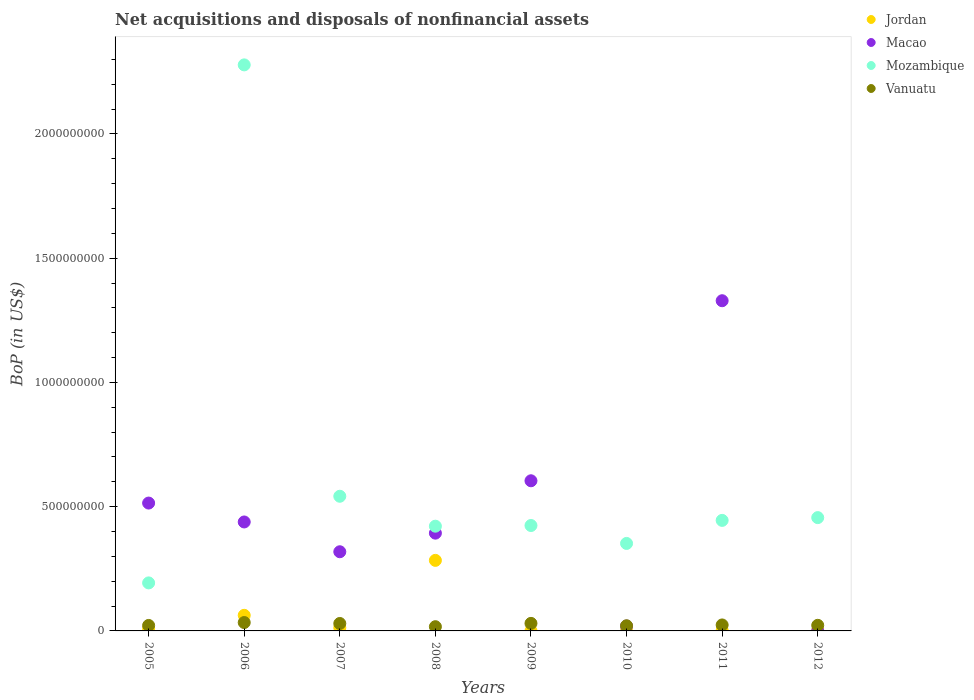How many different coloured dotlines are there?
Ensure brevity in your answer.  4. What is the Balance of Payments in Mozambique in 2011?
Provide a succinct answer. 4.45e+08. Across all years, what is the maximum Balance of Payments in Jordan?
Provide a succinct answer. 2.84e+08. Across all years, what is the minimum Balance of Payments in Macao?
Give a very brief answer. 0. What is the total Balance of Payments in Jordan in the graph?
Offer a terse response. 3.74e+08. What is the difference between the Balance of Payments in Macao in 2006 and that in 2009?
Provide a succinct answer. -1.66e+08. What is the difference between the Balance of Payments in Jordan in 2006 and the Balance of Payments in Macao in 2012?
Keep it short and to the point. 6.28e+07. What is the average Balance of Payments in Mozambique per year?
Your answer should be compact. 6.39e+08. In the year 2010, what is the difference between the Balance of Payments in Mozambique and Balance of Payments in Macao?
Keep it short and to the point. 3.32e+08. In how many years, is the Balance of Payments in Macao greater than 600000000 US$?
Your answer should be very brief. 2. What is the ratio of the Balance of Payments in Vanuatu in 2005 to that in 2011?
Give a very brief answer. 0.92. Is the Balance of Payments in Mozambique in 2007 less than that in 2008?
Make the answer very short. No. Is the difference between the Balance of Payments in Mozambique in 2006 and 2007 greater than the difference between the Balance of Payments in Macao in 2006 and 2007?
Your answer should be compact. Yes. What is the difference between the highest and the second highest Balance of Payments in Mozambique?
Your answer should be compact. 1.74e+09. What is the difference between the highest and the lowest Balance of Payments in Mozambique?
Your response must be concise. 2.08e+09. Is it the case that in every year, the sum of the Balance of Payments in Vanuatu and Balance of Payments in Macao  is greater than the sum of Balance of Payments in Mozambique and Balance of Payments in Jordan?
Provide a short and direct response. No. Is it the case that in every year, the sum of the Balance of Payments in Mozambique and Balance of Payments in Jordan  is greater than the Balance of Payments in Vanuatu?
Your answer should be very brief. Yes. How many years are there in the graph?
Your answer should be very brief. 8. What is the difference between two consecutive major ticks on the Y-axis?
Provide a short and direct response. 5.00e+08. How many legend labels are there?
Your response must be concise. 4. What is the title of the graph?
Provide a succinct answer. Net acquisitions and disposals of nonfinancial assets. Does "Equatorial Guinea" appear as one of the legend labels in the graph?
Give a very brief answer. No. What is the label or title of the X-axis?
Provide a succinct answer. Years. What is the label or title of the Y-axis?
Provide a succinct answer. BoP (in US$). What is the BoP (in US$) of Jordan in 2005?
Your response must be concise. 8.46e+06. What is the BoP (in US$) of Macao in 2005?
Make the answer very short. 5.15e+08. What is the BoP (in US$) in Mozambique in 2005?
Keep it short and to the point. 1.93e+08. What is the BoP (in US$) in Vanuatu in 2005?
Your answer should be compact. 2.21e+07. What is the BoP (in US$) in Jordan in 2006?
Your answer should be compact. 6.28e+07. What is the BoP (in US$) of Macao in 2006?
Provide a short and direct response. 4.38e+08. What is the BoP (in US$) of Mozambique in 2006?
Provide a short and direct response. 2.28e+09. What is the BoP (in US$) of Vanuatu in 2006?
Provide a short and direct response. 3.37e+07. What is the BoP (in US$) of Jordan in 2007?
Your answer should be compact. 1.28e+07. What is the BoP (in US$) of Macao in 2007?
Offer a very short reply. 3.19e+08. What is the BoP (in US$) in Mozambique in 2007?
Ensure brevity in your answer.  5.42e+08. What is the BoP (in US$) in Vanuatu in 2007?
Provide a short and direct response. 3.00e+07. What is the BoP (in US$) in Jordan in 2008?
Offer a terse response. 2.84e+08. What is the BoP (in US$) of Macao in 2008?
Give a very brief answer. 3.93e+08. What is the BoP (in US$) of Mozambique in 2008?
Offer a terse response. 4.21e+08. What is the BoP (in US$) in Vanuatu in 2008?
Give a very brief answer. 1.70e+07. What is the BoP (in US$) of Jordan in 2009?
Offer a very short reply. 5.63e+05. What is the BoP (in US$) in Macao in 2009?
Keep it short and to the point. 6.04e+08. What is the BoP (in US$) in Mozambique in 2009?
Keep it short and to the point. 4.24e+08. What is the BoP (in US$) of Vanuatu in 2009?
Provide a succinct answer. 3.04e+07. What is the BoP (in US$) in Jordan in 2010?
Provide a succinct answer. 2.82e+05. What is the BoP (in US$) in Macao in 2010?
Keep it short and to the point. 1.96e+07. What is the BoP (in US$) in Mozambique in 2010?
Your answer should be compact. 3.52e+08. What is the BoP (in US$) in Vanuatu in 2010?
Your answer should be very brief. 2.07e+07. What is the BoP (in US$) in Jordan in 2011?
Your answer should be compact. 2.25e+06. What is the BoP (in US$) of Macao in 2011?
Offer a terse response. 1.33e+09. What is the BoP (in US$) in Mozambique in 2011?
Offer a terse response. 4.45e+08. What is the BoP (in US$) in Vanuatu in 2011?
Offer a terse response. 2.40e+07. What is the BoP (in US$) of Jordan in 2012?
Give a very brief answer. 2.54e+06. What is the BoP (in US$) of Mozambique in 2012?
Your answer should be compact. 4.56e+08. What is the BoP (in US$) in Vanuatu in 2012?
Give a very brief answer. 2.26e+07. Across all years, what is the maximum BoP (in US$) of Jordan?
Offer a very short reply. 2.84e+08. Across all years, what is the maximum BoP (in US$) of Macao?
Ensure brevity in your answer.  1.33e+09. Across all years, what is the maximum BoP (in US$) in Mozambique?
Provide a succinct answer. 2.28e+09. Across all years, what is the maximum BoP (in US$) in Vanuatu?
Provide a short and direct response. 3.37e+07. Across all years, what is the minimum BoP (in US$) of Jordan?
Offer a very short reply. 2.82e+05. Across all years, what is the minimum BoP (in US$) in Mozambique?
Keep it short and to the point. 1.93e+08. Across all years, what is the minimum BoP (in US$) in Vanuatu?
Offer a terse response. 1.70e+07. What is the total BoP (in US$) of Jordan in the graph?
Provide a succinct answer. 3.74e+08. What is the total BoP (in US$) of Macao in the graph?
Keep it short and to the point. 3.62e+09. What is the total BoP (in US$) in Mozambique in the graph?
Keep it short and to the point. 5.11e+09. What is the total BoP (in US$) in Vanuatu in the graph?
Provide a succinct answer. 2.00e+08. What is the difference between the BoP (in US$) of Jordan in 2005 and that in 2006?
Your answer should be compact. -5.43e+07. What is the difference between the BoP (in US$) of Macao in 2005 and that in 2006?
Your answer should be very brief. 7.61e+07. What is the difference between the BoP (in US$) of Mozambique in 2005 and that in 2006?
Your answer should be very brief. -2.08e+09. What is the difference between the BoP (in US$) of Vanuatu in 2005 and that in 2006?
Provide a succinct answer. -1.17e+07. What is the difference between the BoP (in US$) in Jordan in 2005 and that in 2007?
Offer a very short reply. -4.37e+06. What is the difference between the BoP (in US$) in Macao in 2005 and that in 2007?
Provide a succinct answer. 1.96e+08. What is the difference between the BoP (in US$) in Mozambique in 2005 and that in 2007?
Provide a short and direct response. -3.49e+08. What is the difference between the BoP (in US$) in Vanuatu in 2005 and that in 2007?
Ensure brevity in your answer.  -7.89e+06. What is the difference between the BoP (in US$) of Jordan in 2005 and that in 2008?
Your answer should be very brief. -2.75e+08. What is the difference between the BoP (in US$) of Macao in 2005 and that in 2008?
Keep it short and to the point. 1.21e+08. What is the difference between the BoP (in US$) of Mozambique in 2005 and that in 2008?
Give a very brief answer. -2.28e+08. What is the difference between the BoP (in US$) in Vanuatu in 2005 and that in 2008?
Offer a terse response. 5.06e+06. What is the difference between the BoP (in US$) in Jordan in 2005 and that in 2009?
Provide a succinct answer. 7.90e+06. What is the difference between the BoP (in US$) of Macao in 2005 and that in 2009?
Your answer should be very brief. -8.97e+07. What is the difference between the BoP (in US$) in Mozambique in 2005 and that in 2009?
Make the answer very short. -2.31e+08. What is the difference between the BoP (in US$) in Vanuatu in 2005 and that in 2009?
Make the answer very short. -8.30e+06. What is the difference between the BoP (in US$) of Jordan in 2005 and that in 2010?
Your response must be concise. 8.18e+06. What is the difference between the BoP (in US$) in Macao in 2005 and that in 2010?
Make the answer very short. 4.95e+08. What is the difference between the BoP (in US$) of Mozambique in 2005 and that in 2010?
Your answer should be compact. -1.59e+08. What is the difference between the BoP (in US$) in Vanuatu in 2005 and that in 2010?
Keep it short and to the point. 1.34e+06. What is the difference between the BoP (in US$) in Jordan in 2005 and that in 2011?
Provide a short and direct response. 6.21e+06. What is the difference between the BoP (in US$) in Macao in 2005 and that in 2011?
Make the answer very short. -8.14e+08. What is the difference between the BoP (in US$) of Mozambique in 2005 and that in 2011?
Provide a short and direct response. -2.52e+08. What is the difference between the BoP (in US$) of Vanuatu in 2005 and that in 2011?
Give a very brief answer. -1.98e+06. What is the difference between the BoP (in US$) of Jordan in 2005 and that in 2012?
Provide a short and direct response. 5.93e+06. What is the difference between the BoP (in US$) of Mozambique in 2005 and that in 2012?
Give a very brief answer. -2.63e+08. What is the difference between the BoP (in US$) in Vanuatu in 2005 and that in 2012?
Your response must be concise. -4.97e+05. What is the difference between the BoP (in US$) of Jordan in 2006 and that in 2007?
Provide a short and direct response. 4.99e+07. What is the difference between the BoP (in US$) of Macao in 2006 and that in 2007?
Give a very brief answer. 1.20e+08. What is the difference between the BoP (in US$) in Mozambique in 2006 and that in 2007?
Make the answer very short. 1.74e+09. What is the difference between the BoP (in US$) of Vanuatu in 2006 and that in 2007?
Give a very brief answer. 3.78e+06. What is the difference between the BoP (in US$) in Jordan in 2006 and that in 2008?
Provide a short and direct response. -2.21e+08. What is the difference between the BoP (in US$) of Macao in 2006 and that in 2008?
Your answer should be compact. 4.50e+07. What is the difference between the BoP (in US$) of Mozambique in 2006 and that in 2008?
Ensure brevity in your answer.  1.86e+09. What is the difference between the BoP (in US$) of Vanuatu in 2006 and that in 2008?
Make the answer very short. 1.67e+07. What is the difference between the BoP (in US$) of Jordan in 2006 and that in 2009?
Give a very brief answer. 6.22e+07. What is the difference between the BoP (in US$) in Macao in 2006 and that in 2009?
Provide a short and direct response. -1.66e+08. What is the difference between the BoP (in US$) in Mozambique in 2006 and that in 2009?
Offer a very short reply. 1.85e+09. What is the difference between the BoP (in US$) of Vanuatu in 2006 and that in 2009?
Make the answer very short. 3.37e+06. What is the difference between the BoP (in US$) in Jordan in 2006 and that in 2010?
Offer a terse response. 6.25e+07. What is the difference between the BoP (in US$) of Macao in 2006 and that in 2010?
Offer a very short reply. 4.19e+08. What is the difference between the BoP (in US$) of Mozambique in 2006 and that in 2010?
Offer a terse response. 1.93e+09. What is the difference between the BoP (in US$) of Vanuatu in 2006 and that in 2010?
Provide a succinct answer. 1.30e+07. What is the difference between the BoP (in US$) of Jordan in 2006 and that in 2011?
Make the answer very short. 6.05e+07. What is the difference between the BoP (in US$) in Macao in 2006 and that in 2011?
Provide a succinct answer. -8.90e+08. What is the difference between the BoP (in US$) of Mozambique in 2006 and that in 2011?
Offer a very short reply. 1.83e+09. What is the difference between the BoP (in US$) in Vanuatu in 2006 and that in 2011?
Your answer should be very brief. 9.69e+06. What is the difference between the BoP (in US$) of Jordan in 2006 and that in 2012?
Give a very brief answer. 6.02e+07. What is the difference between the BoP (in US$) in Mozambique in 2006 and that in 2012?
Your response must be concise. 1.82e+09. What is the difference between the BoP (in US$) of Vanuatu in 2006 and that in 2012?
Offer a terse response. 1.12e+07. What is the difference between the BoP (in US$) of Jordan in 2007 and that in 2008?
Offer a very short reply. -2.71e+08. What is the difference between the BoP (in US$) of Macao in 2007 and that in 2008?
Offer a terse response. -7.49e+07. What is the difference between the BoP (in US$) in Mozambique in 2007 and that in 2008?
Provide a succinct answer. 1.20e+08. What is the difference between the BoP (in US$) in Vanuatu in 2007 and that in 2008?
Your answer should be very brief. 1.30e+07. What is the difference between the BoP (in US$) in Jordan in 2007 and that in 2009?
Offer a terse response. 1.23e+07. What is the difference between the BoP (in US$) in Macao in 2007 and that in 2009?
Offer a terse response. -2.86e+08. What is the difference between the BoP (in US$) in Mozambique in 2007 and that in 2009?
Your answer should be compact. 1.18e+08. What is the difference between the BoP (in US$) in Vanuatu in 2007 and that in 2009?
Provide a succinct answer. -4.10e+05. What is the difference between the BoP (in US$) in Jordan in 2007 and that in 2010?
Keep it short and to the point. 1.26e+07. What is the difference between the BoP (in US$) of Macao in 2007 and that in 2010?
Give a very brief answer. 2.99e+08. What is the difference between the BoP (in US$) in Mozambique in 2007 and that in 2010?
Provide a succinct answer. 1.90e+08. What is the difference between the BoP (in US$) in Vanuatu in 2007 and that in 2010?
Offer a very short reply. 9.23e+06. What is the difference between the BoP (in US$) in Jordan in 2007 and that in 2011?
Your answer should be compact. 1.06e+07. What is the difference between the BoP (in US$) of Macao in 2007 and that in 2011?
Offer a very short reply. -1.01e+09. What is the difference between the BoP (in US$) of Mozambique in 2007 and that in 2011?
Offer a terse response. 9.71e+07. What is the difference between the BoP (in US$) in Vanuatu in 2007 and that in 2011?
Offer a very short reply. 5.92e+06. What is the difference between the BoP (in US$) of Jordan in 2007 and that in 2012?
Ensure brevity in your answer.  1.03e+07. What is the difference between the BoP (in US$) in Mozambique in 2007 and that in 2012?
Provide a short and direct response. 8.60e+07. What is the difference between the BoP (in US$) in Vanuatu in 2007 and that in 2012?
Make the answer very short. 7.39e+06. What is the difference between the BoP (in US$) of Jordan in 2008 and that in 2009?
Offer a very short reply. 2.83e+08. What is the difference between the BoP (in US$) in Macao in 2008 and that in 2009?
Offer a very short reply. -2.11e+08. What is the difference between the BoP (in US$) of Mozambique in 2008 and that in 2009?
Your answer should be very brief. -2.73e+06. What is the difference between the BoP (in US$) of Vanuatu in 2008 and that in 2009?
Your response must be concise. -1.34e+07. What is the difference between the BoP (in US$) of Jordan in 2008 and that in 2010?
Your answer should be very brief. 2.84e+08. What is the difference between the BoP (in US$) of Macao in 2008 and that in 2010?
Provide a succinct answer. 3.74e+08. What is the difference between the BoP (in US$) in Mozambique in 2008 and that in 2010?
Keep it short and to the point. 6.94e+07. What is the difference between the BoP (in US$) of Vanuatu in 2008 and that in 2010?
Offer a terse response. -3.72e+06. What is the difference between the BoP (in US$) of Jordan in 2008 and that in 2011?
Your response must be concise. 2.82e+08. What is the difference between the BoP (in US$) of Macao in 2008 and that in 2011?
Your answer should be very brief. -9.35e+08. What is the difference between the BoP (in US$) of Mozambique in 2008 and that in 2011?
Give a very brief answer. -2.33e+07. What is the difference between the BoP (in US$) of Vanuatu in 2008 and that in 2011?
Your answer should be very brief. -7.04e+06. What is the difference between the BoP (in US$) in Jordan in 2008 and that in 2012?
Offer a very short reply. 2.81e+08. What is the difference between the BoP (in US$) in Mozambique in 2008 and that in 2012?
Keep it short and to the point. -3.45e+07. What is the difference between the BoP (in US$) of Vanuatu in 2008 and that in 2012?
Your answer should be very brief. -5.56e+06. What is the difference between the BoP (in US$) of Jordan in 2009 and that in 2010?
Ensure brevity in your answer.  2.82e+05. What is the difference between the BoP (in US$) in Macao in 2009 and that in 2010?
Your response must be concise. 5.85e+08. What is the difference between the BoP (in US$) in Mozambique in 2009 and that in 2010?
Give a very brief answer. 7.21e+07. What is the difference between the BoP (in US$) of Vanuatu in 2009 and that in 2010?
Give a very brief answer. 9.64e+06. What is the difference between the BoP (in US$) in Jordan in 2009 and that in 2011?
Keep it short and to the point. -1.69e+06. What is the difference between the BoP (in US$) of Macao in 2009 and that in 2011?
Provide a short and direct response. -7.25e+08. What is the difference between the BoP (in US$) of Mozambique in 2009 and that in 2011?
Offer a terse response. -2.06e+07. What is the difference between the BoP (in US$) in Vanuatu in 2009 and that in 2011?
Offer a very short reply. 6.33e+06. What is the difference between the BoP (in US$) in Jordan in 2009 and that in 2012?
Make the answer very short. -1.97e+06. What is the difference between the BoP (in US$) in Mozambique in 2009 and that in 2012?
Ensure brevity in your answer.  -3.18e+07. What is the difference between the BoP (in US$) in Vanuatu in 2009 and that in 2012?
Give a very brief answer. 7.80e+06. What is the difference between the BoP (in US$) in Jordan in 2010 and that in 2011?
Offer a very short reply. -1.97e+06. What is the difference between the BoP (in US$) in Macao in 2010 and that in 2011?
Provide a succinct answer. -1.31e+09. What is the difference between the BoP (in US$) of Mozambique in 2010 and that in 2011?
Your answer should be compact. -9.28e+07. What is the difference between the BoP (in US$) of Vanuatu in 2010 and that in 2011?
Your answer should be very brief. -3.31e+06. What is the difference between the BoP (in US$) in Jordan in 2010 and that in 2012?
Offer a terse response. -2.25e+06. What is the difference between the BoP (in US$) in Mozambique in 2010 and that in 2012?
Offer a very short reply. -1.04e+08. What is the difference between the BoP (in US$) in Vanuatu in 2010 and that in 2012?
Your response must be concise. -1.84e+06. What is the difference between the BoP (in US$) of Jordan in 2011 and that in 2012?
Provide a succinct answer. -2.82e+05. What is the difference between the BoP (in US$) in Mozambique in 2011 and that in 2012?
Keep it short and to the point. -1.11e+07. What is the difference between the BoP (in US$) of Vanuatu in 2011 and that in 2012?
Provide a succinct answer. 1.48e+06. What is the difference between the BoP (in US$) of Jordan in 2005 and the BoP (in US$) of Macao in 2006?
Provide a short and direct response. -4.30e+08. What is the difference between the BoP (in US$) in Jordan in 2005 and the BoP (in US$) in Mozambique in 2006?
Offer a very short reply. -2.27e+09. What is the difference between the BoP (in US$) in Jordan in 2005 and the BoP (in US$) in Vanuatu in 2006?
Keep it short and to the point. -2.53e+07. What is the difference between the BoP (in US$) of Macao in 2005 and the BoP (in US$) of Mozambique in 2006?
Provide a short and direct response. -1.76e+09. What is the difference between the BoP (in US$) of Macao in 2005 and the BoP (in US$) of Vanuatu in 2006?
Your answer should be very brief. 4.81e+08. What is the difference between the BoP (in US$) in Mozambique in 2005 and the BoP (in US$) in Vanuatu in 2006?
Offer a very short reply. 1.60e+08. What is the difference between the BoP (in US$) in Jordan in 2005 and the BoP (in US$) in Macao in 2007?
Keep it short and to the point. -3.10e+08. What is the difference between the BoP (in US$) of Jordan in 2005 and the BoP (in US$) of Mozambique in 2007?
Your response must be concise. -5.33e+08. What is the difference between the BoP (in US$) of Jordan in 2005 and the BoP (in US$) of Vanuatu in 2007?
Keep it short and to the point. -2.15e+07. What is the difference between the BoP (in US$) in Macao in 2005 and the BoP (in US$) in Mozambique in 2007?
Your answer should be very brief. -2.74e+07. What is the difference between the BoP (in US$) of Macao in 2005 and the BoP (in US$) of Vanuatu in 2007?
Offer a very short reply. 4.85e+08. What is the difference between the BoP (in US$) of Mozambique in 2005 and the BoP (in US$) of Vanuatu in 2007?
Ensure brevity in your answer.  1.63e+08. What is the difference between the BoP (in US$) of Jordan in 2005 and the BoP (in US$) of Macao in 2008?
Offer a terse response. -3.85e+08. What is the difference between the BoP (in US$) in Jordan in 2005 and the BoP (in US$) in Mozambique in 2008?
Your answer should be very brief. -4.13e+08. What is the difference between the BoP (in US$) in Jordan in 2005 and the BoP (in US$) in Vanuatu in 2008?
Keep it short and to the point. -8.54e+06. What is the difference between the BoP (in US$) of Macao in 2005 and the BoP (in US$) of Mozambique in 2008?
Provide a short and direct response. 9.31e+07. What is the difference between the BoP (in US$) of Macao in 2005 and the BoP (in US$) of Vanuatu in 2008?
Your answer should be very brief. 4.98e+08. What is the difference between the BoP (in US$) of Mozambique in 2005 and the BoP (in US$) of Vanuatu in 2008?
Keep it short and to the point. 1.76e+08. What is the difference between the BoP (in US$) in Jordan in 2005 and the BoP (in US$) in Macao in 2009?
Give a very brief answer. -5.96e+08. What is the difference between the BoP (in US$) in Jordan in 2005 and the BoP (in US$) in Mozambique in 2009?
Ensure brevity in your answer.  -4.16e+08. What is the difference between the BoP (in US$) in Jordan in 2005 and the BoP (in US$) in Vanuatu in 2009?
Keep it short and to the point. -2.19e+07. What is the difference between the BoP (in US$) of Macao in 2005 and the BoP (in US$) of Mozambique in 2009?
Provide a succinct answer. 9.03e+07. What is the difference between the BoP (in US$) in Macao in 2005 and the BoP (in US$) in Vanuatu in 2009?
Keep it short and to the point. 4.84e+08. What is the difference between the BoP (in US$) of Mozambique in 2005 and the BoP (in US$) of Vanuatu in 2009?
Offer a very short reply. 1.63e+08. What is the difference between the BoP (in US$) in Jordan in 2005 and the BoP (in US$) in Macao in 2010?
Ensure brevity in your answer.  -1.11e+07. What is the difference between the BoP (in US$) of Jordan in 2005 and the BoP (in US$) of Mozambique in 2010?
Give a very brief answer. -3.44e+08. What is the difference between the BoP (in US$) in Jordan in 2005 and the BoP (in US$) in Vanuatu in 2010?
Offer a very short reply. -1.23e+07. What is the difference between the BoP (in US$) in Macao in 2005 and the BoP (in US$) in Mozambique in 2010?
Your answer should be compact. 1.62e+08. What is the difference between the BoP (in US$) of Macao in 2005 and the BoP (in US$) of Vanuatu in 2010?
Keep it short and to the point. 4.94e+08. What is the difference between the BoP (in US$) in Mozambique in 2005 and the BoP (in US$) in Vanuatu in 2010?
Offer a terse response. 1.73e+08. What is the difference between the BoP (in US$) in Jordan in 2005 and the BoP (in US$) in Macao in 2011?
Provide a short and direct response. -1.32e+09. What is the difference between the BoP (in US$) of Jordan in 2005 and the BoP (in US$) of Mozambique in 2011?
Your answer should be compact. -4.36e+08. What is the difference between the BoP (in US$) of Jordan in 2005 and the BoP (in US$) of Vanuatu in 2011?
Your answer should be compact. -1.56e+07. What is the difference between the BoP (in US$) in Macao in 2005 and the BoP (in US$) in Mozambique in 2011?
Offer a very short reply. 6.97e+07. What is the difference between the BoP (in US$) of Macao in 2005 and the BoP (in US$) of Vanuatu in 2011?
Provide a succinct answer. 4.91e+08. What is the difference between the BoP (in US$) in Mozambique in 2005 and the BoP (in US$) in Vanuatu in 2011?
Provide a succinct answer. 1.69e+08. What is the difference between the BoP (in US$) of Jordan in 2005 and the BoP (in US$) of Mozambique in 2012?
Keep it short and to the point. -4.48e+08. What is the difference between the BoP (in US$) in Jordan in 2005 and the BoP (in US$) in Vanuatu in 2012?
Provide a succinct answer. -1.41e+07. What is the difference between the BoP (in US$) in Macao in 2005 and the BoP (in US$) in Mozambique in 2012?
Your answer should be compact. 5.86e+07. What is the difference between the BoP (in US$) in Macao in 2005 and the BoP (in US$) in Vanuatu in 2012?
Provide a short and direct response. 4.92e+08. What is the difference between the BoP (in US$) in Mozambique in 2005 and the BoP (in US$) in Vanuatu in 2012?
Your response must be concise. 1.71e+08. What is the difference between the BoP (in US$) in Jordan in 2006 and the BoP (in US$) in Macao in 2007?
Provide a short and direct response. -2.56e+08. What is the difference between the BoP (in US$) of Jordan in 2006 and the BoP (in US$) of Mozambique in 2007?
Your answer should be very brief. -4.79e+08. What is the difference between the BoP (in US$) in Jordan in 2006 and the BoP (in US$) in Vanuatu in 2007?
Your answer should be very brief. 3.28e+07. What is the difference between the BoP (in US$) of Macao in 2006 and the BoP (in US$) of Mozambique in 2007?
Provide a short and direct response. -1.03e+08. What is the difference between the BoP (in US$) of Macao in 2006 and the BoP (in US$) of Vanuatu in 2007?
Offer a terse response. 4.09e+08. What is the difference between the BoP (in US$) of Mozambique in 2006 and the BoP (in US$) of Vanuatu in 2007?
Your answer should be compact. 2.25e+09. What is the difference between the BoP (in US$) in Jordan in 2006 and the BoP (in US$) in Macao in 2008?
Provide a short and direct response. -3.31e+08. What is the difference between the BoP (in US$) of Jordan in 2006 and the BoP (in US$) of Mozambique in 2008?
Offer a terse response. -3.59e+08. What is the difference between the BoP (in US$) in Jordan in 2006 and the BoP (in US$) in Vanuatu in 2008?
Your answer should be very brief. 4.58e+07. What is the difference between the BoP (in US$) in Macao in 2006 and the BoP (in US$) in Mozambique in 2008?
Ensure brevity in your answer.  1.70e+07. What is the difference between the BoP (in US$) of Macao in 2006 and the BoP (in US$) of Vanuatu in 2008?
Offer a terse response. 4.21e+08. What is the difference between the BoP (in US$) in Mozambique in 2006 and the BoP (in US$) in Vanuatu in 2008?
Your response must be concise. 2.26e+09. What is the difference between the BoP (in US$) in Jordan in 2006 and the BoP (in US$) in Macao in 2009?
Give a very brief answer. -5.41e+08. What is the difference between the BoP (in US$) in Jordan in 2006 and the BoP (in US$) in Mozambique in 2009?
Keep it short and to the point. -3.61e+08. What is the difference between the BoP (in US$) of Jordan in 2006 and the BoP (in US$) of Vanuatu in 2009?
Your response must be concise. 3.24e+07. What is the difference between the BoP (in US$) of Macao in 2006 and the BoP (in US$) of Mozambique in 2009?
Your response must be concise. 1.43e+07. What is the difference between the BoP (in US$) in Macao in 2006 and the BoP (in US$) in Vanuatu in 2009?
Keep it short and to the point. 4.08e+08. What is the difference between the BoP (in US$) of Mozambique in 2006 and the BoP (in US$) of Vanuatu in 2009?
Ensure brevity in your answer.  2.25e+09. What is the difference between the BoP (in US$) of Jordan in 2006 and the BoP (in US$) of Macao in 2010?
Offer a terse response. 4.32e+07. What is the difference between the BoP (in US$) of Jordan in 2006 and the BoP (in US$) of Mozambique in 2010?
Keep it short and to the point. -2.89e+08. What is the difference between the BoP (in US$) of Jordan in 2006 and the BoP (in US$) of Vanuatu in 2010?
Provide a succinct answer. 4.20e+07. What is the difference between the BoP (in US$) of Macao in 2006 and the BoP (in US$) of Mozambique in 2010?
Provide a succinct answer. 8.64e+07. What is the difference between the BoP (in US$) of Macao in 2006 and the BoP (in US$) of Vanuatu in 2010?
Offer a terse response. 4.18e+08. What is the difference between the BoP (in US$) of Mozambique in 2006 and the BoP (in US$) of Vanuatu in 2010?
Provide a succinct answer. 2.26e+09. What is the difference between the BoP (in US$) of Jordan in 2006 and the BoP (in US$) of Macao in 2011?
Your answer should be compact. -1.27e+09. What is the difference between the BoP (in US$) of Jordan in 2006 and the BoP (in US$) of Mozambique in 2011?
Your answer should be very brief. -3.82e+08. What is the difference between the BoP (in US$) in Jordan in 2006 and the BoP (in US$) in Vanuatu in 2011?
Offer a very short reply. 3.87e+07. What is the difference between the BoP (in US$) of Macao in 2006 and the BoP (in US$) of Mozambique in 2011?
Ensure brevity in your answer.  -6.35e+06. What is the difference between the BoP (in US$) in Macao in 2006 and the BoP (in US$) in Vanuatu in 2011?
Ensure brevity in your answer.  4.14e+08. What is the difference between the BoP (in US$) in Mozambique in 2006 and the BoP (in US$) in Vanuatu in 2011?
Offer a terse response. 2.25e+09. What is the difference between the BoP (in US$) of Jordan in 2006 and the BoP (in US$) of Mozambique in 2012?
Provide a short and direct response. -3.93e+08. What is the difference between the BoP (in US$) in Jordan in 2006 and the BoP (in US$) in Vanuatu in 2012?
Offer a terse response. 4.02e+07. What is the difference between the BoP (in US$) of Macao in 2006 and the BoP (in US$) of Mozambique in 2012?
Your response must be concise. -1.75e+07. What is the difference between the BoP (in US$) in Macao in 2006 and the BoP (in US$) in Vanuatu in 2012?
Provide a short and direct response. 4.16e+08. What is the difference between the BoP (in US$) in Mozambique in 2006 and the BoP (in US$) in Vanuatu in 2012?
Your answer should be compact. 2.26e+09. What is the difference between the BoP (in US$) in Jordan in 2007 and the BoP (in US$) in Macao in 2008?
Give a very brief answer. -3.81e+08. What is the difference between the BoP (in US$) in Jordan in 2007 and the BoP (in US$) in Mozambique in 2008?
Your answer should be very brief. -4.09e+08. What is the difference between the BoP (in US$) of Jordan in 2007 and the BoP (in US$) of Vanuatu in 2008?
Your answer should be very brief. -4.17e+06. What is the difference between the BoP (in US$) of Macao in 2007 and the BoP (in US$) of Mozambique in 2008?
Offer a very short reply. -1.03e+08. What is the difference between the BoP (in US$) in Macao in 2007 and the BoP (in US$) in Vanuatu in 2008?
Ensure brevity in your answer.  3.02e+08. What is the difference between the BoP (in US$) of Mozambique in 2007 and the BoP (in US$) of Vanuatu in 2008?
Provide a short and direct response. 5.25e+08. What is the difference between the BoP (in US$) of Jordan in 2007 and the BoP (in US$) of Macao in 2009?
Offer a terse response. -5.91e+08. What is the difference between the BoP (in US$) in Jordan in 2007 and the BoP (in US$) in Mozambique in 2009?
Your answer should be very brief. -4.11e+08. What is the difference between the BoP (in US$) of Jordan in 2007 and the BoP (in US$) of Vanuatu in 2009?
Your answer should be very brief. -1.75e+07. What is the difference between the BoP (in US$) in Macao in 2007 and the BoP (in US$) in Mozambique in 2009?
Give a very brief answer. -1.06e+08. What is the difference between the BoP (in US$) in Macao in 2007 and the BoP (in US$) in Vanuatu in 2009?
Your response must be concise. 2.88e+08. What is the difference between the BoP (in US$) in Mozambique in 2007 and the BoP (in US$) in Vanuatu in 2009?
Your answer should be compact. 5.12e+08. What is the difference between the BoP (in US$) in Jordan in 2007 and the BoP (in US$) in Macao in 2010?
Provide a succinct answer. -6.76e+06. What is the difference between the BoP (in US$) of Jordan in 2007 and the BoP (in US$) of Mozambique in 2010?
Keep it short and to the point. -3.39e+08. What is the difference between the BoP (in US$) of Jordan in 2007 and the BoP (in US$) of Vanuatu in 2010?
Make the answer very short. -7.89e+06. What is the difference between the BoP (in US$) in Macao in 2007 and the BoP (in US$) in Mozambique in 2010?
Your response must be concise. -3.35e+07. What is the difference between the BoP (in US$) of Macao in 2007 and the BoP (in US$) of Vanuatu in 2010?
Make the answer very short. 2.98e+08. What is the difference between the BoP (in US$) in Mozambique in 2007 and the BoP (in US$) in Vanuatu in 2010?
Give a very brief answer. 5.21e+08. What is the difference between the BoP (in US$) of Jordan in 2007 and the BoP (in US$) of Macao in 2011?
Provide a succinct answer. -1.32e+09. What is the difference between the BoP (in US$) of Jordan in 2007 and the BoP (in US$) of Mozambique in 2011?
Provide a succinct answer. -4.32e+08. What is the difference between the BoP (in US$) in Jordan in 2007 and the BoP (in US$) in Vanuatu in 2011?
Make the answer very short. -1.12e+07. What is the difference between the BoP (in US$) in Macao in 2007 and the BoP (in US$) in Mozambique in 2011?
Ensure brevity in your answer.  -1.26e+08. What is the difference between the BoP (in US$) of Macao in 2007 and the BoP (in US$) of Vanuatu in 2011?
Give a very brief answer. 2.95e+08. What is the difference between the BoP (in US$) in Mozambique in 2007 and the BoP (in US$) in Vanuatu in 2011?
Give a very brief answer. 5.18e+08. What is the difference between the BoP (in US$) of Jordan in 2007 and the BoP (in US$) of Mozambique in 2012?
Make the answer very short. -4.43e+08. What is the difference between the BoP (in US$) of Jordan in 2007 and the BoP (in US$) of Vanuatu in 2012?
Make the answer very short. -9.73e+06. What is the difference between the BoP (in US$) of Macao in 2007 and the BoP (in US$) of Mozambique in 2012?
Provide a succinct answer. -1.37e+08. What is the difference between the BoP (in US$) of Macao in 2007 and the BoP (in US$) of Vanuatu in 2012?
Provide a succinct answer. 2.96e+08. What is the difference between the BoP (in US$) in Mozambique in 2007 and the BoP (in US$) in Vanuatu in 2012?
Provide a succinct answer. 5.19e+08. What is the difference between the BoP (in US$) in Jordan in 2008 and the BoP (in US$) in Macao in 2009?
Your answer should be compact. -3.20e+08. What is the difference between the BoP (in US$) of Jordan in 2008 and the BoP (in US$) of Mozambique in 2009?
Keep it short and to the point. -1.40e+08. What is the difference between the BoP (in US$) of Jordan in 2008 and the BoP (in US$) of Vanuatu in 2009?
Your response must be concise. 2.54e+08. What is the difference between the BoP (in US$) of Macao in 2008 and the BoP (in US$) of Mozambique in 2009?
Give a very brief answer. -3.07e+07. What is the difference between the BoP (in US$) in Macao in 2008 and the BoP (in US$) in Vanuatu in 2009?
Provide a short and direct response. 3.63e+08. What is the difference between the BoP (in US$) of Mozambique in 2008 and the BoP (in US$) of Vanuatu in 2009?
Offer a very short reply. 3.91e+08. What is the difference between the BoP (in US$) of Jordan in 2008 and the BoP (in US$) of Macao in 2010?
Make the answer very short. 2.64e+08. What is the difference between the BoP (in US$) of Jordan in 2008 and the BoP (in US$) of Mozambique in 2010?
Provide a short and direct response. -6.81e+07. What is the difference between the BoP (in US$) in Jordan in 2008 and the BoP (in US$) in Vanuatu in 2010?
Your answer should be compact. 2.63e+08. What is the difference between the BoP (in US$) in Macao in 2008 and the BoP (in US$) in Mozambique in 2010?
Your answer should be compact. 4.14e+07. What is the difference between the BoP (in US$) of Macao in 2008 and the BoP (in US$) of Vanuatu in 2010?
Offer a terse response. 3.73e+08. What is the difference between the BoP (in US$) of Mozambique in 2008 and the BoP (in US$) of Vanuatu in 2010?
Offer a terse response. 4.01e+08. What is the difference between the BoP (in US$) in Jordan in 2008 and the BoP (in US$) in Macao in 2011?
Provide a succinct answer. -1.04e+09. What is the difference between the BoP (in US$) of Jordan in 2008 and the BoP (in US$) of Mozambique in 2011?
Ensure brevity in your answer.  -1.61e+08. What is the difference between the BoP (in US$) of Jordan in 2008 and the BoP (in US$) of Vanuatu in 2011?
Offer a very short reply. 2.60e+08. What is the difference between the BoP (in US$) in Macao in 2008 and the BoP (in US$) in Mozambique in 2011?
Offer a terse response. -5.13e+07. What is the difference between the BoP (in US$) of Macao in 2008 and the BoP (in US$) of Vanuatu in 2011?
Your response must be concise. 3.69e+08. What is the difference between the BoP (in US$) in Mozambique in 2008 and the BoP (in US$) in Vanuatu in 2011?
Your response must be concise. 3.97e+08. What is the difference between the BoP (in US$) in Jordan in 2008 and the BoP (in US$) in Mozambique in 2012?
Your answer should be compact. -1.72e+08. What is the difference between the BoP (in US$) of Jordan in 2008 and the BoP (in US$) of Vanuatu in 2012?
Give a very brief answer. 2.61e+08. What is the difference between the BoP (in US$) in Macao in 2008 and the BoP (in US$) in Mozambique in 2012?
Provide a short and direct response. -6.25e+07. What is the difference between the BoP (in US$) in Macao in 2008 and the BoP (in US$) in Vanuatu in 2012?
Provide a short and direct response. 3.71e+08. What is the difference between the BoP (in US$) of Mozambique in 2008 and the BoP (in US$) of Vanuatu in 2012?
Your answer should be very brief. 3.99e+08. What is the difference between the BoP (in US$) of Jordan in 2009 and the BoP (in US$) of Macao in 2010?
Give a very brief answer. -1.90e+07. What is the difference between the BoP (in US$) of Jordan in 2009 and the BoP (in US$) of Mozambique in 2010?
Your answer should be compact. -3.52e+08. What is the difference between the BoP (in US$) in Jordan in 2009 and the BoP (in US$) in Vanuatu in 2010?
Ensure brevity in your answer.  -2.02e+07. What is the difference between the BoP (in US$) in Macao in 2009 and the BoP (in US$) in Mozambique in 2010?
Ensure brevity in your answer.  2.52e+08. What is the difference between the BoP (in US$) in Macao in 2009 and the BoP (in US$) in Vanuatu in 2010?
Provide a succinct answer. 5.83e+08. What is the difference between the BoP (in US$) in Mozambique in 2009 and the BoP (in US$) in Vanuatu in 2010?
Your response must be concise. 4.03e+08. What is the difference between the BoP (in US$) in Jordan in 2009 and the BoP (in US$) in Macao in 2011?
Offer a very short reply. -1.33e+09. What is the difference between the BoP (in US$) of Jordan in 2009 and the BoP (in US$) of Mozambique in 2011?
Make the answer very short. -4.44e+08. What is the difference between the BoP (in US$) of Jordan in 2009 and the BoP (in US$) of Vanuatu in 2011?
Keep it short and to the point. -2.35e+07. What is the difference between the BoP (in US$) of Macao in 2009 and the BoP (in US$) of Mozambique in 2011?
Ensure brevity in your answer.  1.59e+08. What is the difference between the BoP (in US$) of Macao in 2009 and the BoP (in US$) of Vanuatu in 2011?
Your answer should be compact. 5.80e+08. What is the difference between the BoP (in US$) of Mozambique in 2009 and the BoP (in US$) of Vanuatu in 2011?
Keep it short and to the point. 4.00e+08. What is the difference between the BoP (in US$) in Jordan in 2009 and the BoP (in US$) in Mozambique in 2012?
Your answer should be compact. -4.55e+08. What is the difference between the BoP (in US$) of Jordan in 2009 and the BoP (in US$) of Vanuatu in 2012?
Make the answer very short. -2.20e+07. What is the difference between the BoP (in US$) in Macao in 2009 and the BoP (in US$) in Mozambique in 2012?
Ensure brevity in your answer.  1.48e+08. What is the difference between the BoP (in US$) in Macao in 2009 and the BoP (in US$) in Vanuatu in 2012?
Make the answer very short. 5.82e+08. What is the difference between the BoP (in US$) of Mozambique in 2009 and the BoP (in US$) of Vanuatu in 2012?
Ensure brevity in your answer.  4.02e+08. What is the difference between the BoP (in US$) of Jordan in 2010 and the BoP (in US$) of Macao in 2011?
Provide a short and direct response. -1.33e+09. What is the difference between the BoP (in US$) of Jordan in 2010 and the BoP (in US$) of Mozambique in 2011?
Make the answer very short. -4.45e+08. What is the difference between the BoP (in US$) of Jordan in 2010 and the BoP (in US$) of Vanuatu in 2011?
Offer a terse response. -2.38e+07. What is the difference between the BoP (in US$) of Macao in 2010 and the BoP (in US$) of Mozambique in 2011?
Keep it short and to the point. -4.25e+08. What is the difference between the BoP (in US$) of Macao in 2010 and the BoP (in US$) of Vanuatu in 2011?
Ensure brevity in your answer.  -4.44e+06. What is the difference between the BoP (in US$) in Mozambique in 2010 and the BoP (in US$) in Vanuatu in 2011?
Offer a terse response. 3.28e+08. What is the difference between the BoP (in US$) of Jordan in 2010 and the BoP (in US$) of Mozambique in 2012?
Your answer should be very brief. -4.56e+08. What is the difference between the BoP (in US$) of Jordan in 2010 and the BoP (in US$) of Vanuatu in 2012?
Offer a terse response. -2.23e+07. What is the difference between the BoP (in US$) of Macao in 2010 and the BoP (in US$) of Mozambique in 2012?
Your answer should be very brief. -4.36e+08. What is the difference between the BoP (in US$) in Macao in 2010 and the BoP (in US$) in Vanuatu in 2012?
Give a very brief answer. -2.97e+06. What is the difference between the BoP (in US$) of Mozambique in 2010 and the BoP (in US$) of Vanuatu in 2012?
Provide a short and direct response. 3.30e+08. What is the difference between the BoP (in US$) of Jordan in 2011 and the BoP (in US$) of Mozambique in 2012?
Provide a short and direct response. -4.54e+08. What is the difference between the BoP (in US$) of Jordan in 2011 and the BoP (in US$) of Vanuatu in 2012?
Your answer should be very brief. -2.03e+07. What is the difference between the BoP (in US$) of Macao in 2011 and the BoP (in US$) of Mozambique in 2012?
Your response must be concise. 8.73e+08. What is the difference between the BoP (in US$) in Macao in 2011 and the BoP (in US$) in Vanuatu in 2012?
Provide a succinct answer. 1.31e+09. What is the difference between the BoP (in US$) of Mozambique in 2011 and the BoP (in US$) of Vanuatu in 2012?
Provide a short and direct response. 4.22e+08. What is the average BoP (in US$) in Jordan per year?
Provide a short and direct response. 4.67e+07. What is the average BoP (in US$) of Macao per year?
Offer a terse response. 4.52e+08. What is the average BoP (in US$) of Mozambique per year?
Your answer should be very brief. 6.39e+08. What is the average BoP (in US$) of Vanuatu per year?
Keep it short and to the point. 2.51e+07. In the year 2005, what is the difference between the BoP (in US$) in Jordan and BoP (in US$) in Macao?
Ensure brevity in your answer.  -5.06e+08. In the year 2005, what is the difference between the BoP (in US$) of Jordan and BoP (in US$) of Mozambique?
Your answer should be compact. -1.85e+08. In the year 2005, what is the difference between the BoP (in US$) in Jordan and BoP (in US$) in Vanuatu?
Ensure brevity in your answer.  -1.36e+07. In the year 2005, what is the difference between the BoP (in US$) in Macao and BoP (in US$) in Mozambique?
Offer a terse response. 3.21e+08. In the year 2005, what is the difference between the BoP (in US$) of Macao and BoP (in US$) of Vanuatu?
Your answer should be very brief. 4.92e+08. In the year 2005, what is the difference between the BoP (in US$) in Mozambique and BoP (in US$) in Vanuatu?
Keep it short and to the point. 1.71e+08. In the year 2006, what is the difference between the BoP (in US$) in Jordan and BoP (in US$) in Macao?
Provide a succinct answer. -3.76e+08. In the year 2006, what is the difference between the BoP (in US$) of Jordan and BoP (in US$) of Mozambique?
Keep it short and to the point. -2.22e+09. In the year 2006, what is the difference between the BoP (in US$) in Jordan and BoP (in US$) in Vanuatu?
Make the answer very short. 2.90e+07. In the year 2006, what is the difference between the BoP (in US$) of Macao and BoP (in US$) of Mozambique?
Ensure brevity in your answer.  -1.84e+09. In the year 2006, what is the difference between the BoP (in US$) of Macao and BoP (in US$) of Vanuatu?
Offer a terse response. 4.05e+08. In the year 2006, what is the difference between the BoP (in US$) in Mozambique and BoP (in US$) in Vanuatu?
Keep it short and to the point. 2.24e+09. In the year 2007, what is the difference between the BoP (in US$) of Jordan and BoP (in US$) of Macao?
Your response must be concise. -3.06e+08. In the year 2007, what is the difference between the BoP (in US$) of Jordan and BoP (in US$) of Mozambique?
Your answer should be very brief. -5.29e+08. In the year 2007, what is the difference between the BoP (in US$) in Jordan and BoP (in US$) in Vanuatu?
Provide a short and direct response. -1.71e+07. In the year 2007, what is the difference between the BoP (in US$) of Macao and BoP (in US$) of Mozambique?
Provide a succinct answer. -2.23e+08. In the year 2007, what is the difference between the BoP (in US$) of Macao and BoP (in US$) of Vanuatu?
Offer a terse response. 2.89e+08. In the year 2007, what is the difference between the BoP (in US$) in Mozambique and BoP (in US$) in Vanuatu?
Offer a very short reply. 5.12e+08. In the year 2008, what is the difference between the BoP (in US$) of Jordan and BoP (in US$) of Macao?
Ensure brevity in your answer.  -1.10e+08. In the year 2008, what is the difference between the BoP (in US$) of Jordan and BoP (in US$) of Mozambique?
Provide a short and direct response. -1.38e+08. In the year 2008, what is the difference between the BoP (in US$) of Jordan and BoP (in US$) of Vanuatu?
Provide a succinct answer. 2.67e+08. In the year 2008, what is the difference between the BoP (in US$) in Macao and BoP (in US$) in Mozambique?
Your answer should be very brief. -2.80e+07. In the year 2008, what is the difference between the BoP (in US$) of Macao and BoP (in US$) of Vanuatu?
Your response must be concise. 3.76e+08. In the year 2008, what is the difference between the BoP (in US$) in Mozambique and BoP (in US$) in Vanuatu?
Offer a terse response. 4.04e+08. In the year 2009, what is the difference between the BoP (in US$) in Jordan and BoP (in US$) in Macao?
Ensure brevity in your answer.  -6.04e+08. In the year 2009, what is the difference between the BoP (in US$) in Jordan and BoP (in US$) in Mozambique?
Give a very brief answer. -4.24e+08. In the year 2009, what is the difference between the BoP (in US$) in Jordan and BoP (in US$) in Vanuatu?
Keep it short and to the point. -2.98e+07. In the year 2009, what is the difference between the BoP (in US$) of Macao and BoP (in US$) of Mozambique?
Give a very brief answer. 1.80e+08. In the year 2009, what is the difference between the BoP (in US$) in Macao and BoP (in US$) in Vanuatu?
Keep it short and to the point. 5.74e+08. In the year 2009, what is the difference between the BoP (in US$) of Mozambique and BoP (in US$) of Vanuatu?
Offer a terse response. 3.94e+08. In the year 2010, what is the difference between the BoP (in US$) in Jordan and BoP (in US$) in Macao?
Your response must be concise. -1.93e+07. In the year 2010, what is the difference between the BoP (in US$) of Jordan and BoP (in US$) of Mozambique?
Your answer should be very brief. -3.52e+08. In the year 2010, what is the difference between the BoP (in US$) of Jordan and BoP (in US$) of Vanuatu?
Offer a very short reply. -2.04e+07. In the year 2010, what is the difference between the BoP (in US$) of Macao and BoP (in US$) of Mozambique?
Ensure brevity in your answer.  -3.32e+08. In the year 2010, what is the difference between the BoP (in US$) of Macao and BoP (in US$) of Vanuatu?
Your response must be concise. -1.13e+06. In the year 2010, what is the difference between the BoP (in US$) of Mozambique and BoP (in US$) of Vanuatu?
Your answer should be compact. 3.31e+08. In the year 2011, what is the difference between the BoP (in US$) in Jordan and BoP (in US$) in Macao?
Your response must be concise. -1.33e+09. In the year 2011, what is the difference between the BoP (in US$) of Jordan and BoP (in US$) of Mozambique?
Your answer should be compact. -4.43e+08. In the year 2011, what is the difference between the BoP (in US$) in Jordan and BoP (in US$) in Vanuatu?
Provide a short and direct response. -2.18e+07. In the year 2011, what is the difference between the BoP (in US$) in Macao and BoP (in US$) in Mozambique?
Make the answer very short. 8.84e+08. In the year 2011, what is the difference between the BoP (in US$) of Macao and BoP (in US$) of Vanuatu?
Offer a very short reply. 1.30e+09. In the year 2011, what is the difference between the BoP (in US$) in Mozambique and BoP (in US$) in Vanuatu?
Your answer should be compact. 4.21e+08. In the year 2012, what is the difference between the BoP (in US$) in Jordan and BoP (in US$) in Mozambique?
Your answer should be compact. -4.53e+08. In the year 2012, what is the difference between the BoP (in US$) in Jordan and BoP (in US$) in Vanuatu?
Your response must be concise. -2.00e+07. In the year 2012, what is the difference between the BoP (in US$) of Mozambique and BoP (in US$) of Vanuatu?
Your answer should be compact. 4.33e+08. What is the ratio of the BoP (in US$) in Jordan in 2005 to that in 2006?
Offer a terse response. 0.13. What is the ratio of the BoP (in US$) in Macao in 2005 to that in 2006?
Keep it short and to the point. 1.17. What is the ratio of the BoP (in US$) of Mozambique in 2005 to that in 2006?
Give a very brief answer. 0.08. What is the ratio of the BoP (in US$) of Vanuatu in 2005 to that in 2006?
Offer a very short reply. 0.65. What is the ratio of the BoP (in US$) of Jordan in 2005 to that in 2007?
Provide a short and direct response. 0.66. What is the ratio of the BoP (in US$) in Macao in 2005 to that in 2007?
Ensure brevity in your answer.  1.61. What is the ratio of the BoP (in US$) in Mozambique in 2005 to that in 2007?
Provide a short and direct response. 0.36. What is the ratio of the BoP (in US$) of Vanuatu in 2005 to that in 2007?
Your answer should be very brief. 0.74. What is the ratio of the BoP (in US$) in Jordan in 2005 to that in 2008?
Give a very brief answer. 0.03. What is the ratio of the BoP (in US$) of Macao in 2005 to that in 2008?
Ensure brevity in your answer.  1.31. What is the ratio of the BoP (in US$) in Mozambique in 2005 to that in 2008?
Offer a terse response. 0.46. What is the ratio of the BoP (in US$) in Vanuatu in 2005 to that in 2008?
Offer a very short reply. 1.3. What is the ratio of the BoP (in US$) in Jordan in 2005 to that in 2009?
Your answer should be compact. 15.02. What is the ratio of the BoP (in US$) of Macao in 2005 to that in 2009?
Provide a succinct answer. 0.85. What is the ratio of the BoP (in US$) in Mozambique in 2005 to that in 2009?
Provide a succinct answer. 0.46. What is the ratio of the BoP (in US$) in Vanuatu in 2005 to that in 2009?
Give a very brief answer. 0.73. What is the ratio of the BoP (in US$) of Jordan in 2005 to that in 2010?
Make the answer very short. 30.04. What is the ratio of the BoP (in US$) in Macao in 2005 to that in 2010?
Provide a succinct answer. 26.26. What is the ratio of the BoP (in US$) in Mozambique in 2005 to that in 2010?
Your answer should be very brief. 0.55. What is the ratio of the BoP (in US$) of Vanuatu in 2005 to that in 2010?
Your response must be concise. 1.06. What is the ratio of the BoP (in US$) in Jordan in 2005 to that in 2011?
Ensure brevity in your answer.  3.76. What is the ratio of the BoP (in US$) of Macao in 2005 to that in 2011?
Your answer should be compact. 0.39. What is the ratio of the BoP (in US$) in Mozambique in 2005 to that in 2011?
Your answer should be compact. 0.43. What is the ratio of the BoP (in US$) of Vanuatu in 2005 to that in 2011?
Offer a very short reply. 0.92. What is the ratio of the BoP (in US$) in Jordan in 2005 to that in 2012?
Your answer should be very brief. 3.34. What is the ratio of the BoP (in US$) in Mozambique in 2005 to that in 2012?
Provide a short and direct response. 0.42. What is the ratio of the BoP (in US$) of Jordan in 2006 to that in 2007?
Your answer should be compact. 4.89. What is the ratio of the BoP (in US$) of Macao in 2006 to that in 2007?
Your response must be concise. 1.38. What is the ratio of the BoP (in US$) of Mozambique in 2006 to that in 2007?
Your answer should be compact. 4.2. What is the ratio of the BoP (in US$) of Vanuatu in 2006 to that in 2007?
Make the answer very short. 1.13. What is the ratio of the BoP (in US$) of Jordan in 2006 to that in 2008?
Offer a terse response. 0.22. What is the ratio of the BoP (in US$) of Macao in 2006 to that in 2008?
Your answer should be compact. 1.11. What is the ratio of the BoP (in US$) of Mozambique in 2006 to that in 2008?
Your answer should be very brief. 5.4. What is the ratio of the BoP (in US$) of Vanuatu in 2006 to that in 2008?
Your response must be concise. 1.98. What is the ratio of the BoP (in US$) in Jordan in 2006 to that in 2009?
Your response must be concise. 111.41. What is the ratio of the BoP (in US$) in Macao in 2006 to that in 2009?
Ensure brevity in your answer.  0.73. What is the ratio of the BoP (in US$) of Mozambique in 2006 to that in 2009?
Your response must be concise. 5.37. What is the ratio of the BoP (in US$) of Vanuatu in 2006 to that in 2009?
Provide a succinct answer. 1.11. What is the ratio of the BoP (in US$) of Jordan in 2006 to that in 2010?
Provide a succinct answer. 222.81. What is the ratio of the BoP (in US$) in Macao in 2006 to that in 2010?
Give a very brief answer. 22.37. What is the ratio of the BoP (in US$) of Mozambique in 2006 to that in 2010?
Your answer should be very brief. 6.47. What is the ratio of the BoP (in US$) in Vanuatu in 2006 to that in 2010?
Your answer should be compact. 1.63. What is the ratio of the BoP (in US$) of Jordan in 2006 to that in 2011?
Offer a terse response. 27.85. What is the ratio of the BoP (in US$) of Macao in 2006 to that in 2011?
Give a very brief answer. 0.33. What is the ratio of the BoP (in US$) in Mozambique in 2006 to that in 2011?
Keep it short and to the point. 5.12. What is the ratio of the BoP (in US$) of Vanuatu in 2006 to that in 2011?
Ensure brevity in your answer.  1.4. What is the ratio of the BoP (in US$) in Jordan in 2006 to that in 2012?
Offer a terse response. 24.76. What is the ratio of the BoP (in US$) in Mozambique in 2006 to that in 2012?
Keep it short and to the point. 5. What is the ratio of the BoP (in US$) in Vanuatu in 2006 to that in 2012?
Provide a short and direct response. 1.5. What is the ratio of the BoP (in US$) in Jordan in 2007 to that in 2008?
Offer a terse response. 0.05. What is the ratio of the BoP (in US$) of Macao in 2007 to that in 2008?
Make the answer very short. 0.81. What is the ratio of the BoP (in US$) of Mozambique in 2007 to that in 2008?
Give a very brief answer. 1.29. What is the ratio of the BoP (in US$) in Vanuatu in 2007 to that in 2008?
Provide a short and direct response. 1.76. What is the ratio of the BoP (in US$) in Jordan in 2007 to that in 2009?
Make the answer very short. 22.78. What is the ratio of the BoP (in US$) of Macao in 2007 to that in 2009?
Give a very brief answer. 0.53. What is the ratio of the BoP (in US$) in Mozambique in 2007 to that in 2009?
Provide a short and direct response. 1.28. What is the ratio of the BoP (in US$) of Vanuatu in 2007 to that in 2009?
Provide a succinct answer. 0.99. What is the ratio of the BoP (in US$) of Jordan in 2007 to that in 2010?
Provide a short and direct response. 45.56. What is the ratio of the BoP (in US$) in Macao in 2007 to that in 2010?
Offer a terse response. 16.26. What is the ratio of the BoP (in US$) in Mozambique in 2007 to that in 2010?
Make the answer very short. 1.54. What is the ratio of the BoP (in US$) of Vanuatu in 2007 to that in 2010?
Provide a short and direct response. 1.45. What is the ratio of the BoP (in US$) of Jordan in 2007 to that in 2011?
Provide a succinct answer. 5.7. What is the ratio of the BoP (in US$) of Macao in 2007 to that in 2011?
Your answer should be compact. 0.24. What is the ratio of the BoP (in US$) in Mozambique in 2007 to that in 2011?
Ensure brevity in your answer.  1.22. What is the ratio of the BoP (in US$) of Vanuatu in 2007 to that in 2011?
Your answer should be compact. 1.25. What is the ratio of the BoP (in US$) of Jordan in 2007 to that in 2012?
Offer a terse response. 5.06. What is the ratio of the BoP (in US$) of Mozambique in 2007 to that in 2012?
Offer a terse response. 1.19. What is the ratio of the BoP (in US$) in Vanuatu in 2007 to that in 2012?
Offer a terse response. 1.33. What is the ratio of the BoP (in US$) of Jordan in 2008 to that in 2009?
Provide a short and direct response. 503.95. What is the ratio of the BoP (in US$) in Macao in 2008 to that in 2009?
Offer a very short reply. 0.65. What is the ratio of the BoP (in US$) of Mozambique in 2008 to that in 2009?
Make the answer very short. 0.99. What is the ratio of the BoP (in US$) in Vanuatu in 2008 to that in 2009?
Your response must be concise. 0.56. What is the ratio of the BoP (in US$) in Jordan in 2008 to that in 2010?
Give a very brief answer. 1007.9. What is the ratio of the BoP (in US$) in Macao in 2008 to that in 2010?
Offer a very short reply. 20.08. What is the ratio of the BoP (in US$) in Mozambique in 2008 to that in 2010?
Provide a short and direct response. 1.2. What is the ratio of the BoP (in US$) in Vanuatu in 2008 to that in 2010?
Provide a succinct answer. 0.82. What is the ratio of the BoP (in US$) of Jordan in 2008 to that in 2011?
Your response must be concise. 125.99. What is the ratio of the BoP (in US$) of Macao in 2008 to that in 2011?
Your answer should be very brief. 0.3. What is the ratio of the BoP (in US$) of Mozambique in 2008 to that in 2011?
Keep it short and to the point. 0.95. What is the ratio of the BoP (in US$) in Vanuatu in 2008 to that in 2011?
Provide a succinct answer. 0.71. What is the ratio of the BoP (in US$) in Jordan in 2008 to that in 2012?
Your answer should be compact. 111.99. What is the ratio of the BoP (in US$) in Mozambique in 2008 to that in 2012?
Provide a succinct answer. 0.92. What is the ratio of the BoP (in US$) of Vanuatu in 2008 to that in 2012?
Your answer should be very brief. 0.75. What is the ratio of the BoP (in US$) in Jordan in 2009 to that in 2010?
Offer a very short reply. 2. What is the ratio of the BoP (in US$) in Macao in 2009 to that in 2010?
Your response must be concise. 30.83. What is the ratio of the BoP (in US$) of Mozambique in 2009 to that in 2010?
Your answer should be compact. 1.2. What is the ratio of the BoP (in US$) of Vanuatu in 2009 to that in 2010?
Make the answer very short. 1.47. What is the ratio of the BoP (in US$) in Macao in 2009 to that in 2011?
Provide a succinct answer. 0.45. What is the ratio of the BoP (in US$) in Mozambique in 2009 to that in 2011?
Offer a very short reply. 0.95. What is the ratio of the BoP (in US$) in Vanuatu in 2009 to that in 2011?
Your answer should be compact. 1.26. What is the ratio of the BoP (in US$) in Jordan in 2009 to that in 2012?
Give a very brief answer. 0.22. What is the ratio of the BoP (in US$) of Mozambique in 2009 to that in 2012?
Provide a short and direct response. 0.93. What is the ratio of the BoP (in US$) in Vanuatu in 2009 to that in 2012?
Your answer should be very brief. 1.35. What is the ratio of the BoP (in US$) in Jordan in 2010 to that in 2011?
Ensure brevity in your answer.  0.12. What is the ratio of the BoP (in US$) in Macao in 2010 to that in 2011?
Your answer should be compact. 0.01. What is the ratio of the BoP (in US$) of Mozambique in 2010 to that in 2011?
Your response must be concise. 0.79. What is the ratio of the BoP (in US$) of Vanuatu in 2010 to that in 2011?
Your answer should be compact. 0.86. What is the ratio of the BoP (in US$) of Mozambique in 2010 to that in 2012?
Offer a very short reply. 0.77. What is the ratio of the BoP (in US$) in Vanuatu in 2010 to that in 2012?
Offer a very short reply. 0.92. What is the ratio of the BoP (in US$) in Jordan in 2011 to that in 2012?
Give a very brief answer. 0.89. What is the ratio of the BoP (in US$) of Mozambique in 2011 to that in 2012?
Give a very brief answer. 0.98. What is the ratio of the BoP (in US$) of Vanuatu in 2011 to that in 2012?
Give a very brief answer. 1.07. What is the difference between the highest and the second highest BoP (in US$) of Jordan?
Your answer should be very brief. 2.21e+08. What is the difference between the highest and the second highest BoP (in US$) in Macao?
Your answer should be very brief. 7.25e+08. What is the difference between the highest and the second highest BoP (in US$) of Mozambique?
Keep it short and to the point. 1.74e+09. What is the difference between the highest and the second highest BoP (in US$) in Vanuatu?
Give a very brief answer. 3.37e+06. What is the difference between the highest and the lowest BoP (in US$) of Jordan?
Your answer should be very brief. 2.84e+08. What is the difference between the highest and the lowest BoP (in US$) in Macao?
Keep it short and to the point. 1.33e+09. What is the difference between the highest and the lowest BoP (in US$) of Mozambique?
Provide a succinct answer. 2.08e+09. What is the difference between the highest and the lowest BoP (in US$) of Vanuatu?
Your answer should be compact. 1.67e+07. 